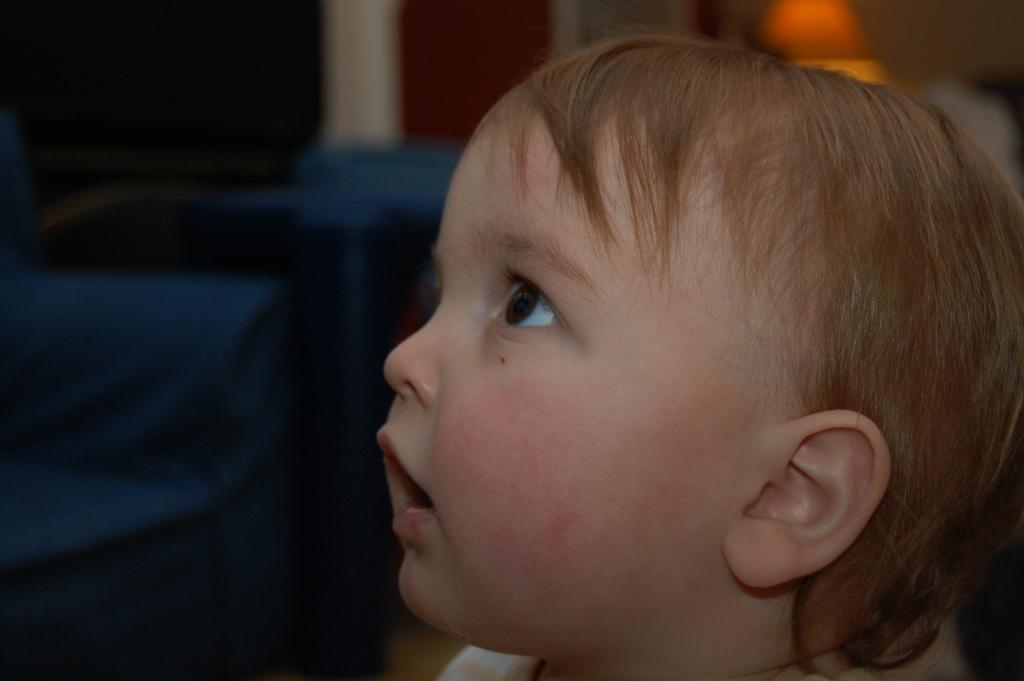What is the main subject of the image? There is a baby in the center of the image. What can be seen in the background of the image? There is a wall, a light, sofas, and other objects visible in the background of the image. What type of song is the baby singing in the image? There is no indication that the baby is singing in the image. --- Facts: 1. There is a car in the image. 2. The car is red. 3. The car has four wheels. 4. There is a road in the image. 5. The road is paved. Absurd Topics: bird, ocean, mountain Conversation: What is the main subject of the image? The main subject of the image is a car. What color is the car? The car is red. How many wheels does the car have? The car has four wheels. What can be seen in the background of the image? There is a road in the image. What is the condition of the road? The road is paved. Reasoning: Let's think step by step in order to produce the conversation. We start by identifying the main subject of the image, which is the car. Next, we describe specific features of the car, such as its color and the number of wheels it has. Then, we observe the background of the image, noting that there is a road present. Finally, we describe the condition of the road, which is paved. Absurd Question/Answer: What type of bird can be seen flying over the car in the image? There is no bird visible in the image. 